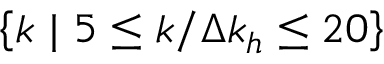<formula> <loc_0><loc_0><loc_500><loc_500>\left \{ k | 5 \leq k / \Delta k _ { h } \leq 2 0 \right \}</formula> 